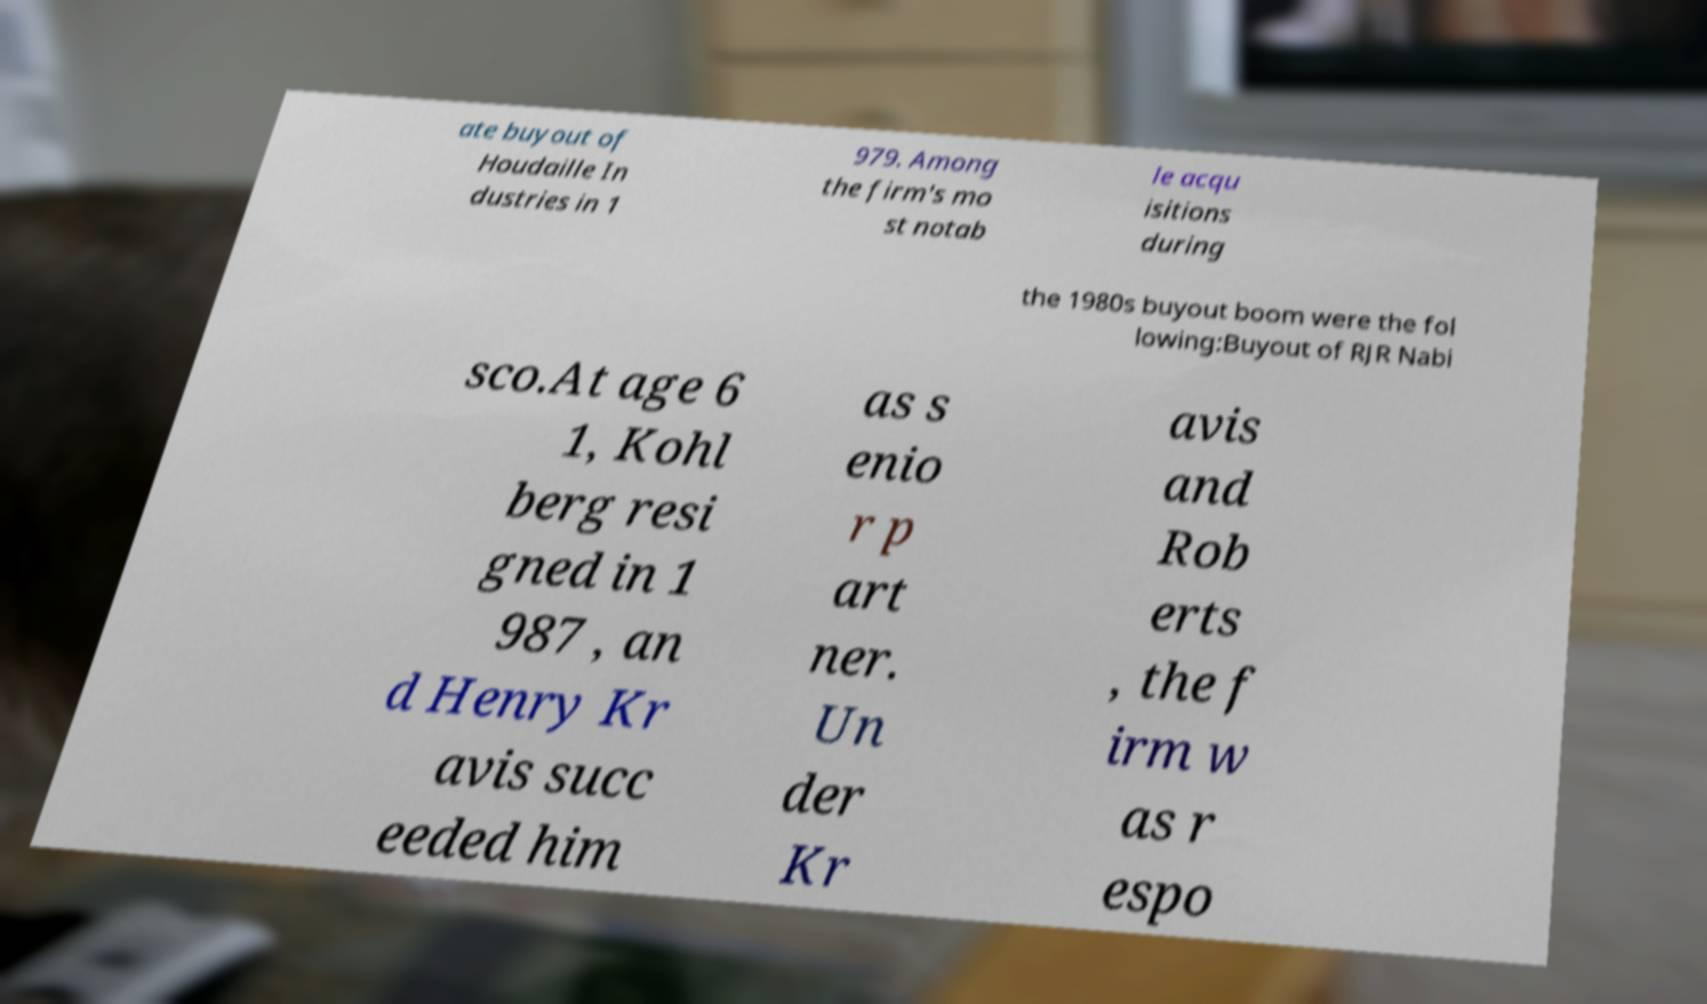There's text embedded in this image that I need extracted. Can you transcribe it verbatim? ate buyout of Houdaille In dustries in 1 979. Among the firm's mo st notab le acqu isitions during the 1980s buyout boom were the fol lowing:Buyout of RJR Nabi sco.At age 6 1, Kohl berg resi gned in 1 987 , an d Henry Kr avis succ eeded him as s enio r p art ner. Un der Kr avis and Rob erts , the f irm w as r espo 